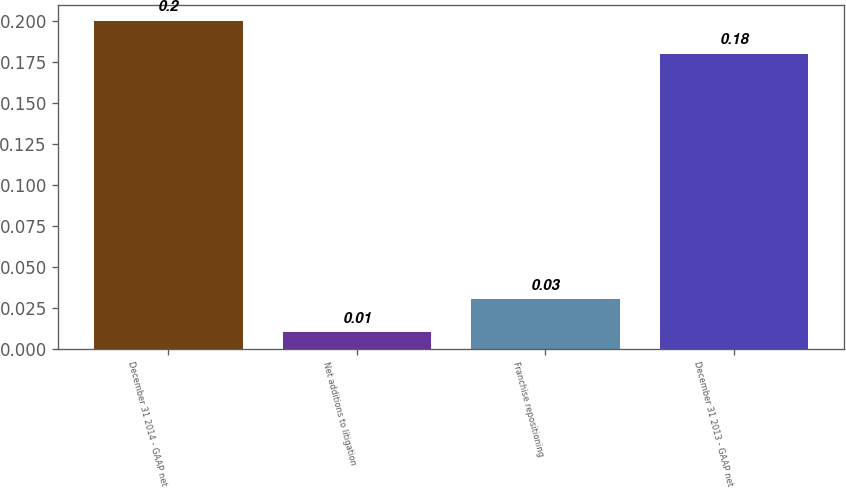<chart> <loc_0><loc_0><loc_500><loc_500><bar_chart><fcel>December 31 2014 - GAAP net<fcel>Net additions to litigation<fcel>Franchise repositioning<fcel>December 31 2013 - GAAP net<nl><fcel>0.2<fcel>0.01<fcel>0.03<fcel>0.18<nl></chart> 